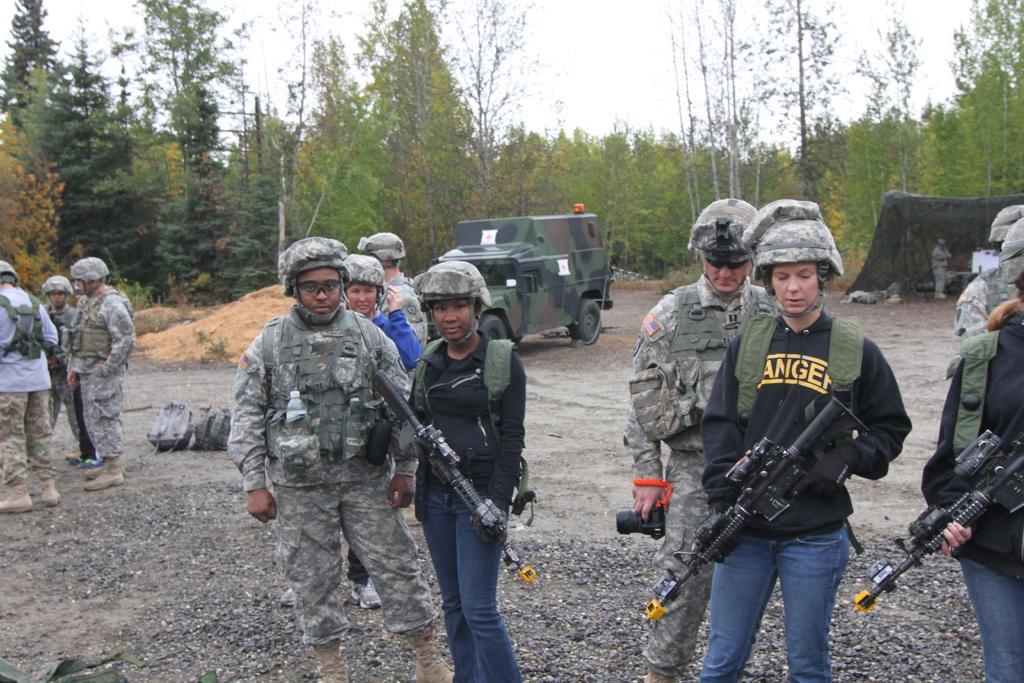Could you give a brief overview of what you see in this image? In this picture I can see there are few people standing and on to right I can see there are few people holding weapons and they are wearing army uniforms,bags, helmets, there are few more people standing they are wearing army uniforms at right is holding a cameras, there are two bags placed on the floor. There are a group of people standing at left and there is a vehicle in the backdrop and there are trees and the sky is clear. 